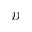Convert formula to latex. <formula><loc_0><loc_0><loc_500><loc_500>\mathcal { D }</formula> 